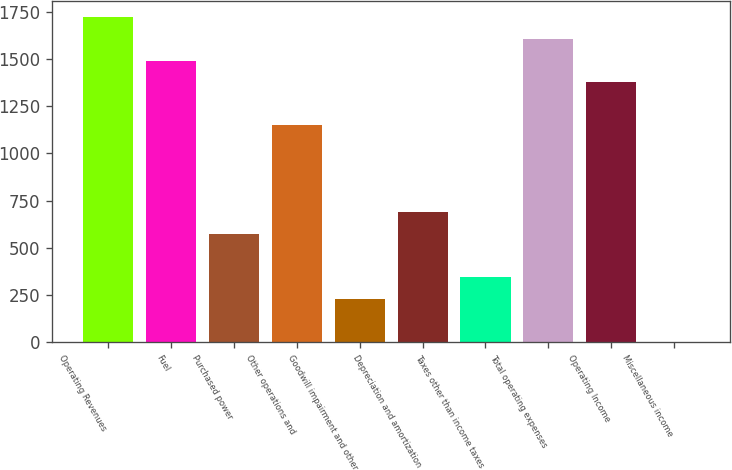<chart> <loc_0><loc_0><loc_500><loc_500><bar_chart><fcel>Operating Revenues<fcel>Fuel<fcel>Purchased power<fcel>Other operations and<fcel>Goodwill impairment and other<fcel>Depreciation and amortization<fcel>Taxes other than income taxes<fcel>Total operating expenses<fcel>Operating Income<fcel>Miscellaneous income<nl><fcel>1721.5<fcel>1492.1<fcel>574.5<fcel>1148<fcel>230.4<fcel>689.2<fcel>345.1<fcel>1606.8<fcel>1377.4<fcel>1<nl></chart> 